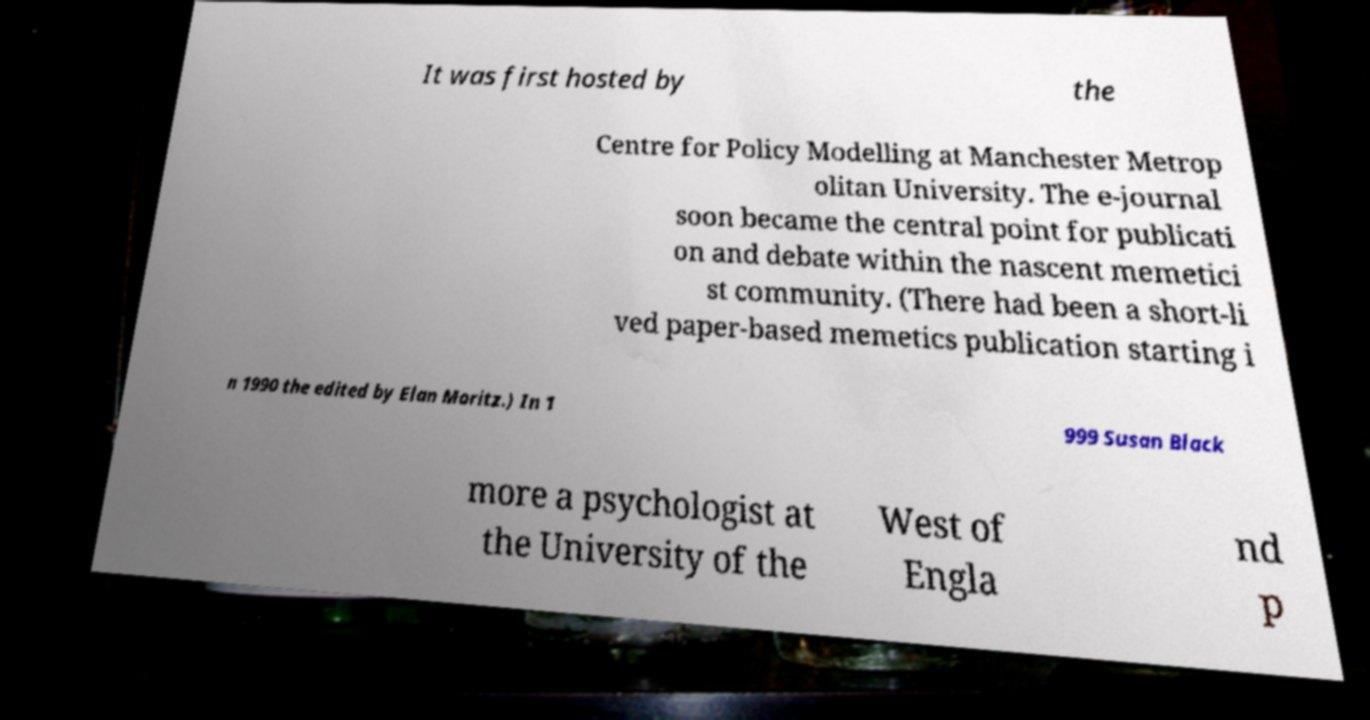What messages or text are displayed in this image? I need them in a readable, typed format. It was first hosted by the Centre for Policy Modelling at Manchester Metrop olitan University. The e-journal soon became the central point for publicati on and debate within the nascent memetici st community. (There had been a short-li ved paper-based memetics publication starting i n 1990 the edited by Elan Moritz.) In 1 999 Susan Black more a psychologist at the University of the West of Engla nd p 